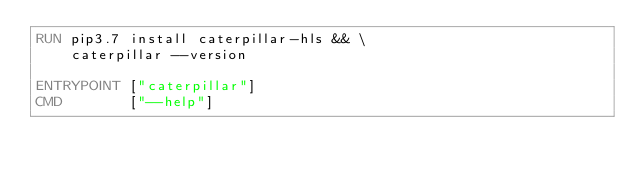Convert code to text. <code><loc_0><loc_0><loc_500><loc_500><_Dockerfile_>RUN pip3.7 install caterpillar-hls && \
    caterpillar --version

ENTRYPOINT ["caterpillar"]
CMD        ["--help"]
</code> 